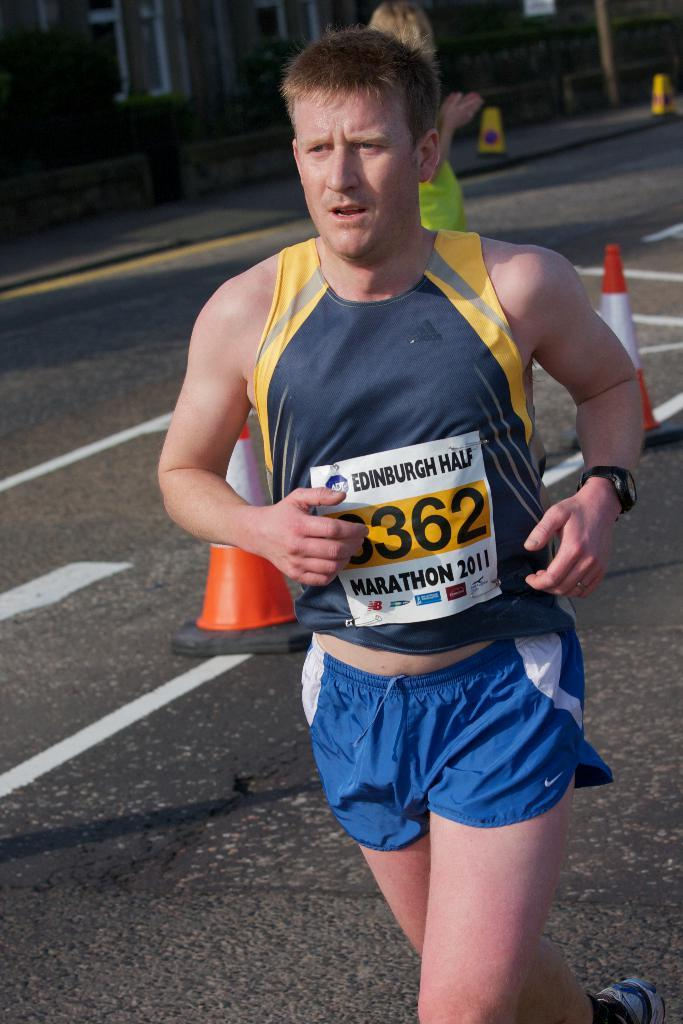Provide a one-sentence caption for the provided image. an edinburgh half marathon runner running his marathon. 